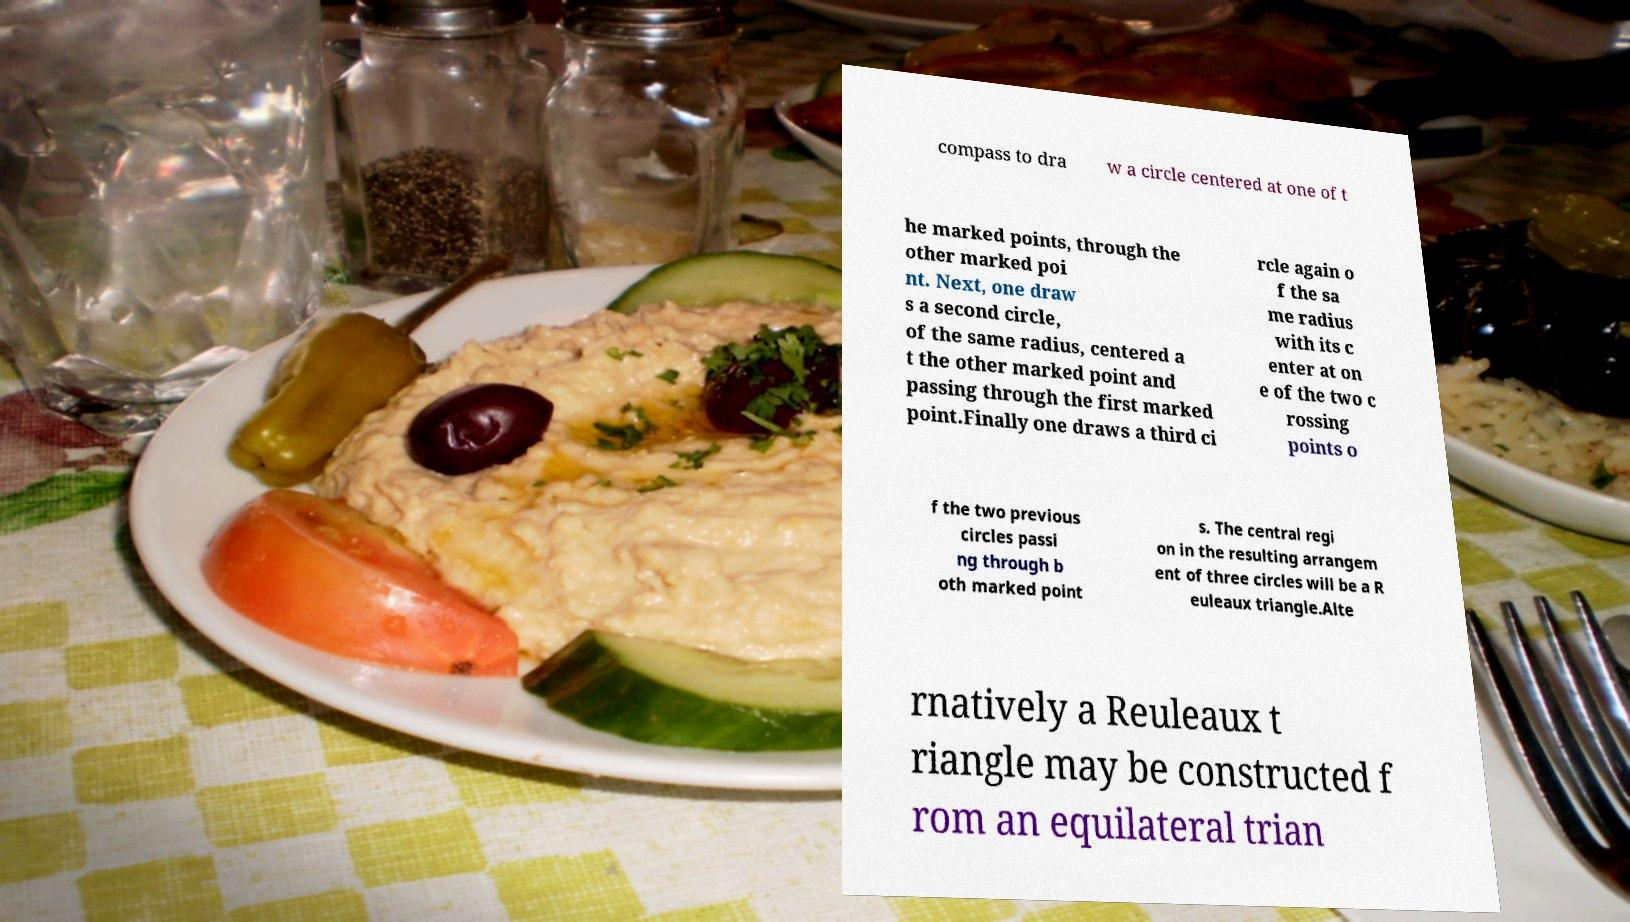There's text embedded in this image that I need extracted. Can you transcribe it verbatim? compass to dra w a circle centered at one of t he marked points, through the other marked poi nt. Next, one draw s a second circle, of the same radius, centered a t the other marked point and passing through the first marked point.Finally one draws a third ci rcle again o f the sa me radius with its c enter at on e of the two c rossing points o f the two previous circles passi ng through b oth marked point s. The central regi on in the resulting arrangem ent of three circles will be a R euleaux triangle.Alte rnatively a Reuleaux t riangle may be constructed f rom an equilateral trian 